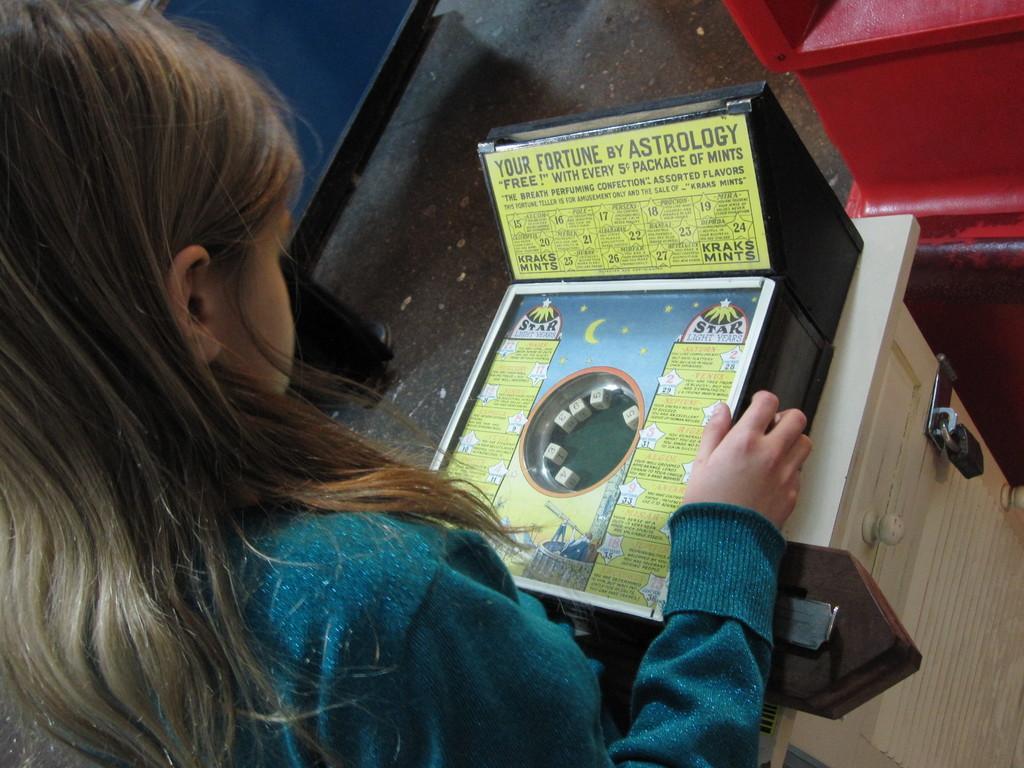Describe this image in one or two sentences. In this image, we can see a person wearing clothes and looking at the game box. 